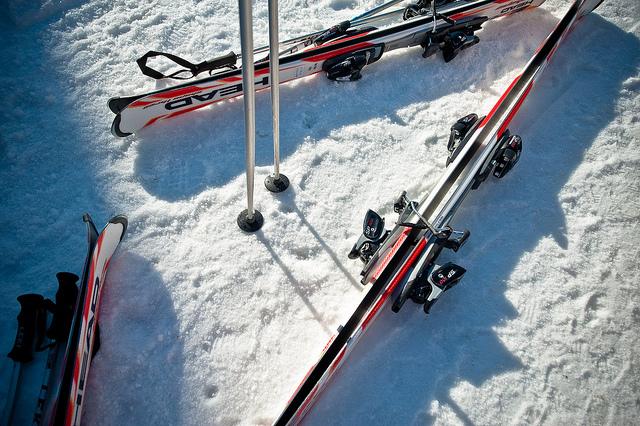Are these all HEAD skis?
Be succinct. Yes. What color is the ground?
Keep it brief. White. Are there people in the picture?
Quick response, please. No. 